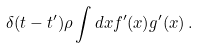Convert formula to latex. <formula><loc_0><loc_0><loc_500><loc_500>\delta ( t - t ^ { \prime } ) \rho \int d x f ^ { \prime } ( x ) g ^ { \prime } ( x ) \, .</formula> 